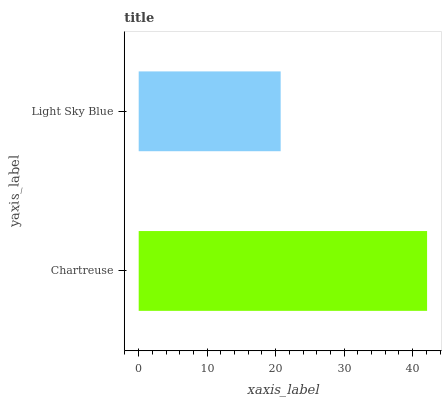Is Light Sky Blue the minimum?
Answer yes or no. Yes. Is Chartreuse the maximum?
Answer yes or no. Yes. Is Light Sky Blue the maximum?
Answer yes or no. No. Is Chartreuse greater than Light Sky Blue?
Answer yes or no. Yes. Is Light Sky Blue less than Chartreuse?
Answer yes or no. Yes. Is Light Sky Blue greater than Chartreuse?
Answer yes or no. No. Is Chartreuse less than Light Sky Blue?
Answer yes or no. No. Is Chartreuse the high median?
Answer yes or no. Yes. Is Light Sky Blue the low median?
Answer yes or no. Yes. Is Light Sky Blue the high median?
Answer yes or no. No. Is Chartreuse the low median?
Answer yes or no. No. 